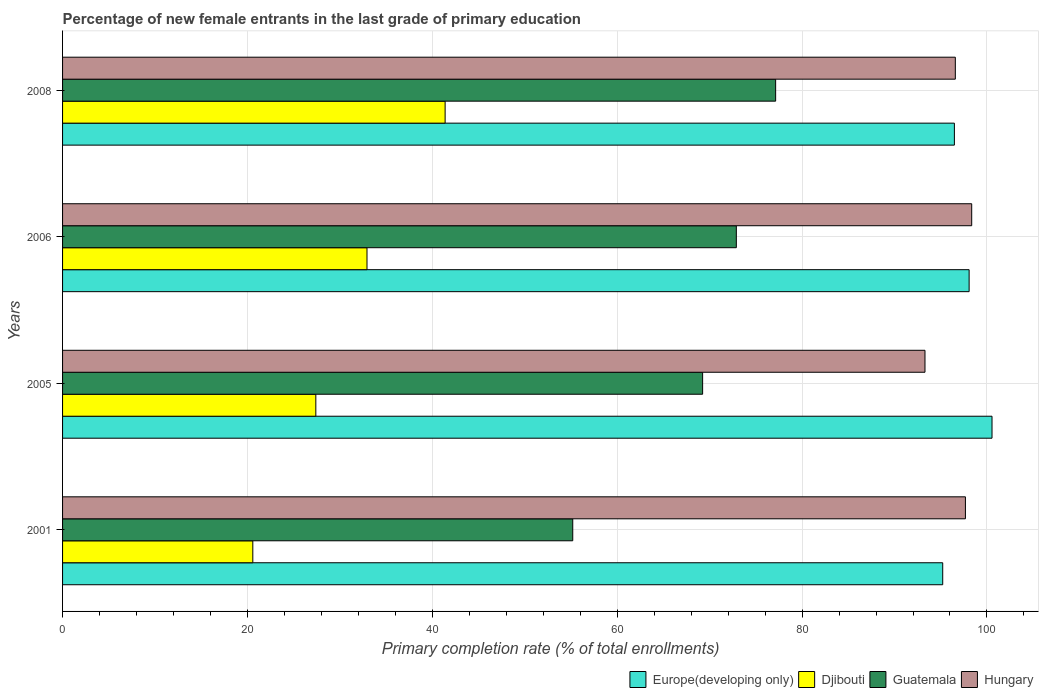How many different coloured bars are there?
Offer a terse response. 4. How many groups of bars are there?
Give a very brief answer. 4. Are the number of bars per tick equal to the number of legend labels?
Offer a terse response. Yes. Are the number of bars on each tick of the Y-axis equal?
Offer a very short reply. Yes. How many bars are there on the 2nd tick from the top?
Your response must be concise. 4. How many bars are there on the 4th tick from the bottom?
Provide a succinct answer. 4. What is the percentage of new female entrants in Europe(developing only) in 2005?
Your answer should be very brief. 100.55. Across all years, what is the maximum percentage of new female entrants in Europe(developing only)?
Ensure brevity in your answer.  100.55. Across all years, what is the minimum percentage of new female entrants in Europe(developing only)?
Your answer should be very brief. 95.21. In which year was the percentage of new female entrants in Europe(developing only) maximum?
Your answer should be compact. 2005. In which year was the percentage of new female entrants in Guatemala minimum?
Give a very brief answer. 2001. What is the total percentage of new female entrants in Hungary in the graph?
Keep it short and to the point. 385.9. What is the difference between the percentage of new female entrants in Djibouti in 2001 and that in 2005?
Keep it short and to the point. -6.82. What is the difference between the percentage of new female entrants in Guatemala in 2006 and the percentage of new female entrants in Hungary in 2005?
Provide a short and direct response. -20.41. What is the average percentage of new female entrants in Guatemala per year?
Make the answer very short. 68.62. In the year 2005, what is the difference between the percentage of new female entrants in Europe(developing only) and percentage of new female entrants in Hungary?
Your answer should be very brief. 7.25. What is the ratio of the percentage of new female entrants in Hungary in 2001 to that in 2006?
Provide a short and direct response. 0.99. Is the percentage of new female entrants in Djibouti in 2001 less than that in 2008?
Offer a terse response. Yes. Is the difference between the percentage of new female entrants in Europe(developing only) in 2001 and 2008 greater than the difference between the percentage of new female entrants in Hungary in 2001 and 2008?
Provide a succinct answer. No. What is the difference between the highest and the second highest percentage of new female entrants in Hungary?
Your answer should be compact. 0.68. What is the difference between the highest and the lowest percentage of new female entrants in Djibouti?
Your response must be concise. 20.8. In how many years, is the percentage of new female entrants in Europe(developing only) greater than the average percentage of new female entrants in Europe(developing only) taken over all years?
Your answer should be compact. 2. Is the sum of the percentage of new female entrants in Djibouti in 2001 and 2005 greater than the maximum percentage of new female entrants in Hungary across all years?
Your answer should be very brief. No. Is it the case that in every year, the sum of the percentage of new female entrants in Hungary and percentage of new female entrants in Guatemala is greater than the sum of percentage of new female entrants in Europe(developing only) and percentage of new female entrants in Djibouti?
Keep it short and to the point. No. What does the 2nd bar from the top in 2006 represents?
Offer a very short reply. Guatemala. What does the 3rd bar from the bottom in 2001 represents?
Your answer should be very brief. Guatemala. Is it the case that in every year, the sum of the percentage of new female entrants in Djibouti and percentage of new female entrants in Hungary is greater than the percentage of new female entrants in Guatemala?
Your response must be concise. Yes. Are all the bars in the graph horizontal?
Offer a terse response. Yes. What is the difference between two consecutive major ticks on the X-axis?
Give a very brief answer. 20. Are the values on the major ticks of X-axis written in scientific E-notation?
Keep it short and to the point. No. Where does the legend appear in the graph?
Keep it short and to the point. Bottom right. How many legend labels are there?
Make the answer very short. 4. How are the legend labels stacked?
Provide a short and direct response. Horizontal. What is the title of the graph?
Offer a very short reply. Percentage of new female entrants in the last grade of primary education. What is the label or title of the X-axis?
Your answer should be compact. Primary completion rate (% of total enrollments). What is the label or title of the Y-axis?
Keep it short and to the point. Years. What is the Primary completion rate (% of total enrollments) of Europe(developing only) in 2001?
Make the answer very short. 95.21. What is the Primary completion rate (% of total enrollments) of Djibouti in 2001?
Your answer should be compact. 20.58. What is the Primary completion rate (% of total enrollments) of Guatemala in 2001?
Your answer should be very brief. 55.19. What is the Primary completion rate (% of total enrollments) of Hungary in 2001?
Ensure brevity in your answer.  97.67. What is the Primary completion rate (% of total enrollments) of Europe(developing only) in 2005?
Give a very brief answer. 100.55. What is the Primary completion rate (% of total enrollments) in Djibouti in 2005?
Offer a very short reply. 27.4. What is the Primary completion rate (% of total enrollments) of Guatemala in 2005?
Your answer should be very brief. 69.24. What is the Primary completion rate (% of total enrollments) in Hungary in 2005?
Offer a terse response. 93.3. What is the Primary completion rate (% of total enrollments) of Europe(developing only) in 2006?
Offer a very short reply. 98.07. What is the Primary completion rate (% of total enrollments) of Djibouti in 2006?
Your response must be concise. 32.93. What is the Primary completion rate (% of total enrollments) of Guatemala in 2006?
Your answer should be compact. 72.89. What is the Primary completion rate (% of total enrollments) of Hungary in 2006?
Provide a succinct answer. 98.35. What is the Primary completion rate (% of total enrollments) of Europe(developing only) in 2008?
Ensure brevity in your answer.  96.48. What is the Primary completion rate (% of total enrollments) of Djibouti in 2008?
Offer a terse response. 41.38. What is the Primary completion rate (% of total enrollments) of Guatemala in 2008?
Provide a short and direct response. 77.14. What is the Primary completion rate (% of total enrollments) of Hungary in 2008?
Provide a short and direct response. 96.58. Across all years, what is the maximum Primary completion rate (% of total enrollments) in Europe(developing only)?
Your response must be concise. 100.55. Across all years, what is the maximum Primary completion rate (% of total enrollments) of Djibouti?
Your answer should be compact. 41.38. Across all years, what is the maximum Primary completion rate (% of total enrollments) of Guatemala?
Make the answer very short. 77.14. Across all years, what is the maximum Primary completion rate (% of total enrollments) of Hungary?
Provide a short and direct response. 98.35. Across all years, what is the minimum Primary completion rate (% of total enrollments) of Europe(developing only)?
Offer a terse response. 95.21. Across all years, what is the minimum Primary completion rate (% of total enrollments) in Djibouti?
Ensure brevity in your answer.  20.58. Across all years, what is the minimum Primary completion rate (% of total enrollments) of Guatemala?
Keep it short and to the point. 55.19. Across all years, what is the minimum Primary completion rate (% of total enrollments) in Hungary?
Your answer should be very brief. 93.3. What is the total Primary completion rate (% of total enrollments) in Europe(developing only) in the graph?
Offer a terse response. 390.31. What is the total Primary completion rate (% of total enrollments) in Djibouti in the graph?
Your answer should be very brief. 122.3. What is the total Primary completion rate (% of total enrollments) of Guatemala in the graph?
Your answer should be compact. 274.46. What is the total Primary completion rate (% of total enrollments) of Hungary in the graph?
Your response must be concise. 385.9. What is the difference between the Primary completion rate (% of total enrollments) in Europe(developing only) in 2001 and that in 2005?
Your answer should be very brief. -5.33. What is the difference between the Primary completion rate (% of total enrollments) of Djibouti in 2001 and that in 2005?
Make the answer very short. -6.82. What is the difference between the Primary completion rate (% of total enrollments) of Guatemala in 2001 and that in 2005?
Offer a terse response. -14.05. What is the difference between the Primary completion rate (% of total enrollments) of Hungary in 2001 and that in 2005?
Offer a very short reply. 4.37. What is the difference between the Primary completion rate (% of total enrollments) in Europe(developing only) in 2001 and that in 2006?
Provide a succinct answer. -2.86. What is the difference between the Primary completion rate (% of total enrollments) in Djibouti in 2001 and that in 2006?
Offer a terse response. -12.35. What is the difference between the Primary completion rate (% of total enrollments) of Guatemala in 2001 and that in 2006?
Ensure brevity in your answer.  -17.7. What is the difference between the Primary completion rate (% of total enrollments) in Hungary in 2001 and that in 2006?
Provide a short and direct response. -0.68. What is the difference between the Primary completion rate (% of total enrollments) in Europe(developing only) in 2001 and that in 2008?
Your answer should be very brief. -1.26. What is the difference between the Primary completion rate (% of total enrollments) of Djibouti in 2001 and that in 2008?
Offer a terse response. -20.8. What is the difference between the Primary completion rate (% of total enrollments) in Guatemala in 2001 and that in 2008?
Ensure brevity in your answer.  -21.95. What is the difference between the Primary completion rate (% of total enrollments) of Hungary in 2001 and that in 2008?
Keep it short and to the point. 1.09. What is the difference between the Primary completion rate (% of total enrollments) in Europe(developing only) in 2005 and that in 2006?
Give a very brief answer. 2.48. What is the difference between the Primary completion rate (% of total enrollments) in Djibouti in 2005 and that in 2006?
Offer a terse response. -5.53. What is the difference between the Primary completion rate (% of total enrollments) of Guatemala in 2005 and that in 2006?
Offer a terse response. -3.65. What is the difference between the Primary completion rate (% of total enrollments) of Hungary in 2005 and that in 2006?
Keep it short and to the point. -5.05. What is the difference between the Primary completion rate (% of total enrollments) of Europe(developing only) in 2005 and that in 2008?
Keep it short and to the point. 4.07. What is the difference between the Primary completion rate (% of total enrollments) of Djibouti in 2005 and that in 2008?
Provide a short and direct response. -13.99. What is the difference between the Primary completion rate (% of total enrollments) in Guatemala in 2005 and that in 2008?
Your response must be concise. -7.9. What is the difference between the Primary completion rate (% of total enrollments) in Hungary in 2005 and that in 2008?
Offer a terse response. -3.28. What is the difference between the Primary completion rate (% of total enrollments) of Europe(developing only) in 2006 and that in 2008?
Provide a succinct answer. 1.59. What is the difference between the Primary completion rate (% of total enrollments) in Djibouti in 2006 and that in 2008?
Ensure brevity in your answer.  -8.45. What is the difference between the Primary completion rate (% of total enrollments) in Guatemala in 2006 and that in 2008?
Ensure brevity in your answer.  -4.25. What is the difference between the Primary completion rate (% of total enrollments) of Hungary in 2006 and that in 2008?
Give a very brief answer. 1.77. What is the difference between the Primary completion rate (% of total enrollments) in Europe(developing only) in 2001 and the Primary completion rate (% of total enrollments) in Djibouti in 2005?
Your answer should be compact. 67.82. What is the difference between the Primary completion rate (% of total enrollments) in Europe(developing only) in 2001 and the Primary completion rate (% of total enrollments) in Guatemala in 2005?
Your answer should be compact. 25.97. What is the difference between the Primary completion rate (% of total enrollments) in Europe(developing only) in 2001 and the Primary completion rate (% of total enrollments) in Hungary in 2005?
Your answer should be very brief. 1.92. What is the difference between the Primary completion rate (% of total enrollments) in Djibouti in 2001 and the Primary completion rate (% of total enrollments) in Guatemala in 2005?
Your answer should be compact. -48.66. What is the difference between the Primary completion rate (% of total enrollments) of Djibouti in 2001 and the Primary completion rate (% of total enrollments) of Hungary in 2005?
Offer a terse response. -72.72. What is the difference between the Primary completion rate (% of total enrollments) in Guatemala in 2001 and the Primary completion rate (% of total enrollments) in Hungary in 2005?
Give a very brief answer. -38.11. What is the difference between the Primary completion rate (% of total enrollments) of Europe(developing only) in 2001 and the Primary completion rate (% of total enrollments) of Djibouti in 2006?
Your response must be concise. 62.28. What is the difference between the Primary completion rate (% of total enrollments) in Europe(developing only) in 2001 and the Primary completion rate (% of total enrollments) in Guatemala in 2006?
Provide a succinct answer. 22.33. What is the difference between the Primary completion rate (% of total enrollments) of Europe(developing only) in 2001 and the Primary completion rate (% of total enrollments) of Hungary in 2006?
Give a very brief answer. -3.14. What is the difference between the Primary completion rate (% of total enrollments) in Djibouti in 2001 and the Primary completion rate (% of total enrollments) in Guatemala in 2006?
Provide a short and direct response. -52.31. What is the difference between the Primary completion rate (% of total enrollments) in Djibouti in 2001 and the Primary completion rate (% of total enrollments) in Hungary in 2006?
Your response must be concise. -77.77. What is the difference between the Primary completion rate (% of total enrollments) of Guatemala in 2001 and the Primary completion rate (% of total enrollments) of Hungary in 2006?
Offer a terse response. -43.16. What is the difference between the Primary completion rate (% of total enrollments) of Europe(developing only) in 2001 and the Primary completion rate (% of total enrollments) of Djibouti in 2008?
Keep it short and to the point. 53.83. What is the difference between the Primary completion rate (% of total enrollments) in Europe(developing only) in 2001 and the Primary completion rate (% of total enrollments) in Guatemala in 2008?
Keep it short and to the point. 18.07. What is the difference between the Primary completion rate (% of total enrollments) in Europe(developing only) in 2001 and the Primary completion rate (% of total enrollments) in Hungary in 2008?
Provide a succinct answer. -1.36. What is the difference between the Primary completion rate (% of total enrollments) in Djibouti in 2001 and the Primary completion rate (% of total enrollments) in Guatemala in 2008?
Make the answer very short. -56.56. What is the difference between the Primary completion rate (% of total enrollments) in Djibouti in 2001 and the Primary completion rate (% of total enrollments) in Hungary in 2008?
Provide a succinct answer. -76. What is the difference between the Primary completion rate (% of total enrollments) of Guatemala in 2001 and the Primary completion rate (% of total enrollments) of Hungary in 2008?
Offer a very short reply. -41.39. What is the difference between the Primary completion rate (% of total enrollments) of Europe(developing only) in 2005 and the Primary completion rate (% of total enrollments) of Djibouti in 2006?
Offer a very short reply. 67.61. What is the difference between the Primary completion rate (% of total enrollments) in Europe(developing only) in 2005 and the Primary completion rate (% of total enrollments) in Guatemala in 2006?
Offer a terse response. 27.66. What is the difference between the Primary completion rate (% of total enrollments) in Europe(developing only) in 2005 and the Primary completion rate (% of total enrollments) in Hungary in 2006?
Offer a very short reply. 2.2. What is the difference between the Primary completion rate (% of total enrollments) in Djibouti in 2005 and the Primary completion rate (% of total enrollments) in Guatemala in 2006?
Your response must be concise. -45.49. What is the difference between the Primary completion rate (% of total enrollments) in Djibouti in 2005 and the Primary completion rate (% of total enrollments) in Hungary in 2006?
Ensure brevity in your answer.  -70.95. What is the difference between the Primary completion rate (% of total enrollments) in Guatemala in 2005 and the Primary completion rate (% of total enrollments) in Hungary in 2006?
Make the answer very short. -29.11. What is the difference between the Primary completion rate (% of total enrollments) of Europe(developing only) in 2005 and the Primary completion rate (% of total enrollments) of Djibouti in 2008?
Your answer should be compact. 59.16. What is the difference between the Primary completion rate (% of total enrollments) in Europe(developing only) in 2005 and the Primary completion rate (% of total enrollments) in Guatemala in 2008?
Provide a succinct answer. 23.41. What is the difference between the Primary completion rate (% of total enrollments) in Europe(developing only) in 2005 and the Primary completion rate (% of total enrollments) in Hungary in 2008?
Give a very brief answer. 3.97. What is the difference between the Primary completion rate (% of total enrollments) of Djibouti in 2005 and the Primary completion rate (% of total enrollments) of Guatemala in 2008?
Offer a very short reply. -49.74. What is the difference between the Primary completion rate (% of total enrollments) of Djibouti in 2005 and the Primary completion rate (% of total enrollments) of Hungary in 2008?
Offer a very short reply. -69.18. What is the difference between the Primary completion rate (% of total enrollments) of Guatemala in 2005 and the Primary completion rate (% of total enrollments) of Hungary in 2008?
Offer a terse response. -27.34. What is the difference between the Primary completion rate (% of total enrollments) in Europe(developing only) in 2006 and the Primary completion rate (% of total enrollments) in Djibouti in 2008?
Offer a very short reply. 56.69. What is the difference between the Primary completion rate (% of total enrollments) in Europe(developing only) in 2006 and the Primary completion rate (% of total enrollments) in Guatemala in 2008?
Keep it short and to the point. 20.93. What is the difference between the Primary completion rate (% of total enrollments) in Europe(developing only) in 2006 and the Primary completion rate (% of total enrollments) in Hungary in 2008?
Your answer should be compact. 1.49. What is the difference between the Primary completion rate (% of total enrollments) of Djibouti in 2006 and the Primary completion rate (% of total enrollments) of Guatemala in 2008?
Your answer should be compact. -44.21. What is the difference between the Primary completion rate (% of total enrollments) in Djibouti in 2006 and the Primary completion rate (% of total enrollments) in Hungary in 2008?
Your response must be concise. -63.65. What is the difference between the Primary completion rate (% of total enrollments) in Guatemala in 2006 and the Primary completion rate (% of total enrollments) in Hungary in 2008?
Your answer should be compact. -23.69. What is the average Primary completion rate (% of total enrollments) in Europe(developing only) per year?
Your response must be concise. 97.58. What is the average Primary completion rate (% of total enrollments) of Djibouti per year?
Keep it short and to the point. 30.57. What is the average Primary completion rate (% of total enrollments) in Guatemala per year?
Offer a terse response. 68.61. What is the average Primary completion rate (% of total enrollments) in Hungary per year?
Your answer should be very brief. 96.47. In the year 2001, what is the difference between the Primary completion rate (% of total enrollments) in Europe(developing only) and Primary completion rate (% of total enrollments) in Djibouti?
Give a very brief answer. 74.63. In the year 2001, what is the difference between the Primary completion rate (% of total enrollments) in Europe(developing only) and Primary completion rate (% of total enrollments) in Guatemala?
Make the answer very short. 40.02. In the year 2001, what is the difference between the Primary completion rate (% of total enrollments) of Europe(developing only) and Primary completion rate (% of total enrollments) of Hungary?
Offer a terse response. -2.46. In the year 2001, what is the difference between the Primary completion rate (% of total enrollments) of Djibouti and Primary completion rate (% of total enrollments) of Guatemala?
Provide a succinct answer. -34.61. In the year 2001, what is the difference between the Primary completion rate (% of total enrollments) in Djibouti and Primary completion rate (% of total enrollments) in Hungary?
Your answer should be very brief. -77.09. In the year 2001, what is the difference between the Primary completion rate (% of total enrollments) in Guatemala and Primary completion rate (% of total enrollments) in Hungary?
Offer a terse response. -42.48. In the year 2005, what is the difference between the Primary completion rate (% of total enrollments) in Europe(developing only) and Primary completion rate (% of total enrollments) in Djibouti?
Provide a succinct answer. 73.15. In the year 2005, what is the difference between the Primary completion rate (% of total enrollments) of Europe(developing only) and Primary completion rate (% of total enrollments) of Guatemala?
Make the answer very short. 31.31. In the year 2005, what is the difference between the Primary completion rate (% of total enrollments) in Europe(developing only) and Primary completion rate (% of total enrollments) in Hungary?
Your answer should be very brief. 7.25. In the year 2005, what is the difference between the Primary completion rate (% of total enrollments) in Djibouti and Primary completion rate (% of total enrollments) in Guatemala?
Offer a very short reply. -41.84. In the year 2005, what is the difference between the Primary completion rate (% of total enrollments) of Djibouti and Primary completion rate (% of total enrollments) of Hungary?
Ensure brevity in your answer.  -65.9. In the year 2005, what is the difference between the Primary completion rate (% of total enrollments) of Guatemala and Primary completion rate (% of total enrollments) of Hungary?
Make the answer very short. -24.06. In the year 2006, what is the difference between the Primary completion rate (% of total enrollments) of Europe(developing only) and Primary completion rate (% of total enrollments) of Djibouti?
Give a very brief answer. 65.14. In the year 2006, what is the difference between the Primary completion rate (% of total enrollments) in Europe(developing only) and Primary completion rate (% of total enrollments) in Guatemala?
Your answer should be compact. 25.18. In the year 2006, what is the difference between the Primary completion rate (% of total enrollments) of Europe(developing only) and Primary completion rate (% of total enrollments) of Hungary?
Provide a succinct answer. -0.28. In the year 2006, what is the difference between the Primary completion rate (% of total enrollments) in Djibouti and Primary completion rate (% of total enrollments) in Guatemala?
Give a very brief answer. -39.95. In the year 2006, what is the difference between the Primary completion rate (% of total enrollments) of Djibouti and Primary completion rate (% of total enrollments) of Hungary?
Make the answer very short. -65.42. In the year 2006, what is the difference between the Primary completion rate (% of total enrollments) of Guatemala and Primary completion rate (% of total enrollments) of Hungary?
Offer a very short reply. -25.46. In the year 2008, what is the difference between the Primary completion rate (% of total enrollments) of Europe(developing only) and Primary completion rate (% of total enrollments) of Djibouti?
Give a very brief answer. 55.09. In the year 2008, what is the difference between the Primary completion rate (% of total enrollments) in Europe(developing only) and Primary completion rate (% of total enrollments) in Guatemala?
Your answer should be compact. 19.34. In the year 2008, what is the difference between the Primary completion rate (% of total enrollments) in Europe(developing only) and Primary completion rate (% of total enrollments) in Hungary?
Ensure brevity in your answer.  -0.1. In the year 2008, what is the difference between the Primary completion rate (% of total enrollments) of Djibouti and Primary completion rate (% of total enrollments) of Guatemala?
Offer a very short reply. -35.76. In the year 2008, what is the difference between the Primary completion rate (% of total enrollments) in Djibouti and Primary completion rate (% of total enrollments) in Hungary?
Your answer should be very brief. -55.19. In the year 2008, what is the difference between the Primary completion rate (% of total enrollments) of Guatemala and Primary completion rate (% of total enrollments) of Hungary?
Make the answer very short. -19.44. What is the ratio of the Primary completion rate (% of total enrollments) in Europe(developing only) in 2001 to that in 2005?
Give a very brief answer. 0.95. What is the ratio of the Primary completion rate (% of total enrollments) in Djibouti in 2001 to that in 2005?
Your answer should be very brief. 0.75. What is the ratio of the Primary completion rate (% of total enrollments) of Guatemala in 2001 to that in 2005?
Ensure brevity in your answer.  0.8. What is the ratio of the Primary completion rate (% of total enrollments) of Hungary in 2001 to that in 2005?
Make the answer very short. 1.05. What is the ratio of the Primary completion rate (% of total enrollments) in Europe(developing only) in 2001 to that in 2006?
Your answer should be very brief. 0.97. What is the ratio of the Primary completion rate (% of total enrollments) in Djibouti in 2001 to that in 2006?
Your response must be concise. 0.62. What is the ratio of the Primary completion rate (% of total enrollments) of Guatemala in 2001 to that in 2006?
Ensure brevity in your answer.  0.76. What is the ratio of the Primary completion rate (% of total enrollments) of Europe(developing only) in 2001 to that in 2008?
Your response must be concise. 0.99. What is the ratio of the Primary completion rate (% of total enrollments) in Djibouti in 2001 to that in 2008?
Your answer should be compact. 0.5. What is the ratio of the Primary completion rate (% of total enrollments) in Guatemala in 2001 to that in 2008?
Your response must be concise. 0.72. What is the ratio of the Primary completion rate (% of total enrollments) of Hungary in 2001 to that in 2008?
Ensure brevity in your answer.  1.01. What is the ratio of the Primary completion rate (% of total enrollments) in Europe(developing only) in 2005 to that in 2006?
Make the answer very short. 1.03. What is the ratio of the Primary completion rate (% of total enrollments) of Djibouti in 2005 to that in 2006?
Your response must be concise. 0.83. What is the ratio of the Primary completion rate (% of total enrollments) of Hungary in 2005 to that in 2006?
Your answer should be very brief. 0.95. What is the ratio of the Primary completion rate (% of total enrollments) of Europe(developing only) in 2005 to that in 2008?
Provide a short and direct response. 1.04. What is the ratio of the Primary completion rate (% of total enrollments) of Djibouti in 2005 to that in 2008?
Ensure brevity in your answer.  0.66. What is the ratio of the Primary completion rate (% of total enrollments) in Guatemala in 2005 to that in 2008?
Ensure brevity in your answer.  0.9. What is the ratio of the Primary completion rate (% of total enrollments) of Hungary in 2005 to that in 2008?
Your response must be concise. 0.97. What is the ratio of the Primary completion rate (% of total enrollments) in Europe(developing only) in 2006 to that in 2008?
Offer a terse response. 1.02. What is the ratio of the Primary completion rate (% of total enrollments) of Djibouti in 2006 to that in 2008?
Make the answer very short. 0.8. What is the ratio of the Primary completion rate (% of total enrollments) in Guatemala in 2006 to that in 2008?
Provide a succinct answer. 0.94. What is the ratio of the Primary completion rate (% of total enrollments) in Hungary in 2006 to that in 2008?
Your answer should be compact. 1.02. What is the difference between the highest and the second highest Primary completion rate (% of total enrollments) of Europe(developing only)?
Ensure brevity in your answer.  2.48. What is the difference between the highest and the second highest Primary completion rate (% of total enrollments) of Djibouti?
Give a very brief answer. 8.45. What is the difference between the highest and the second highest Primary completion rate (% of total enrollments) in Guatemala?
Offer a terse response. 4.25. What is the difference between the highest and the second highest Primary completion rate (% of total enrollments) of Hungary?
Your answer should be very brief. 0.68. What is the difference between the highest and the lowest Primary completion rate (% of total enrollments) of Europe(developing only)?
Offer a terse response. 5.33. What is the difference between the highest and the lowest Primary completion rate (% of total enrollments) of Djibouti?
Make the answer very short. 20.8. What is the difference between the highest and the lowest Primary completion rate (% of total enrollments) of Guatemala?
Keep it short and to the point. 21.95. What is the difference between the highest and the lowest Primary completion rate (% of total enrollments) of Hungary?
Offer a terse response. 5.05. 